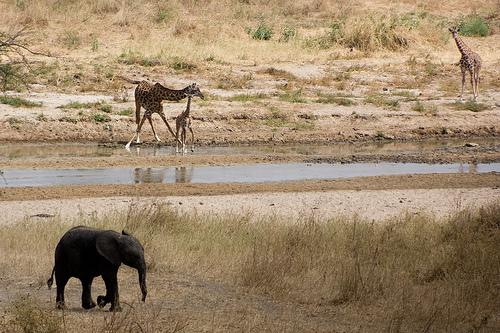Question: who took the picture?
Choices:
A. A boy or a girl.
B. A toddler or an adult.
C. A man or woman.
D. A teenager or a baby.
Answer with the letter. Answer: C Question: how many animals are there in the photo?
Choices:
A. Five.
B. Six.
C. Four.
D. Seven.
Answer with the letter. Answer: C Question: what are the animals doing?
Choices:
A. Sleeping.
B. Eating.
C. Running.
D. Walking.
Answer with the letter. Answer: D Question: what color is the elephant?
Choices:
A. White.
B. Gray.
C. Black.
D. Red.
Answer with the letter. Answer: B 